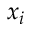Convert formula to latex. <formula><loc_0><loc_0><loc_500><loc_500>x _ { i }</formula> 